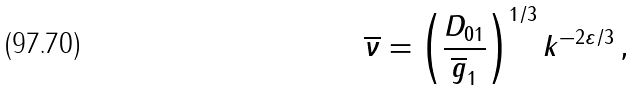<formula> <loc_0><loc_0><loc_500><loc_500>\overline { \nu } = \left ( \frac { D _ { 0 1 } } { { \overline { g } } _ { 1 } } \right ) ^ { 1 / 3 } k ^ { - 2 \varepsilon / 3 } \, ,</formula> 